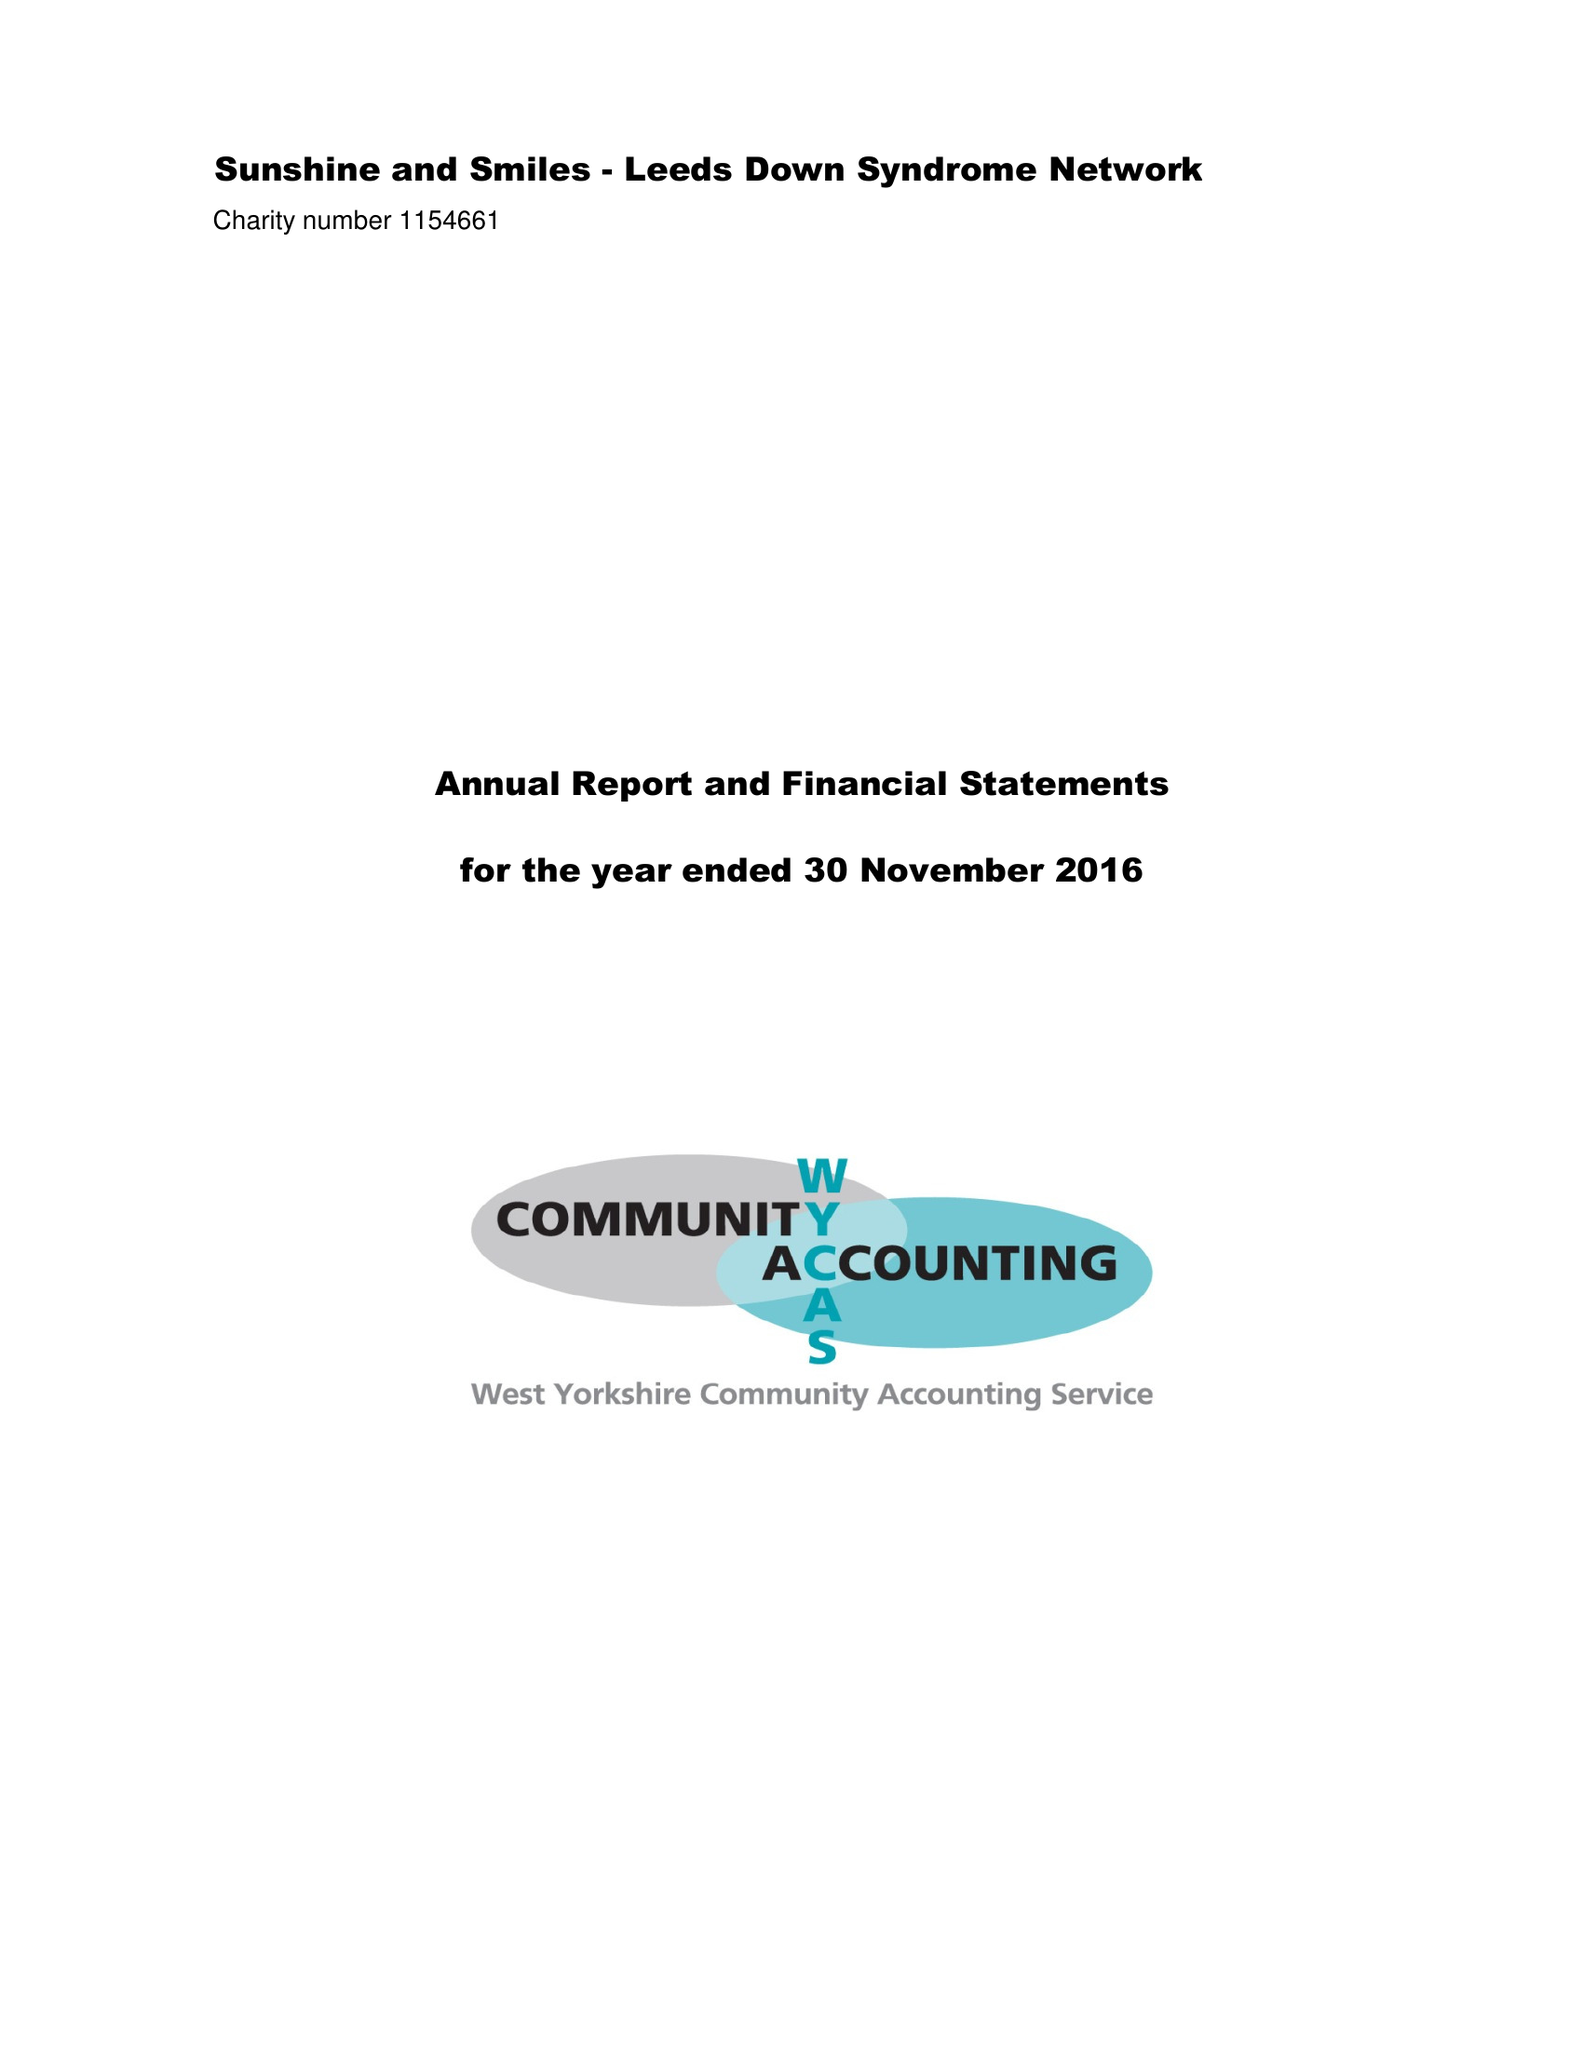What is the value for the address__post_town?
Answer the question using a single word or phrase. LEEDS 